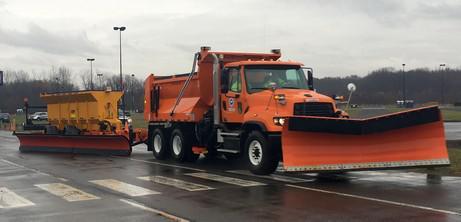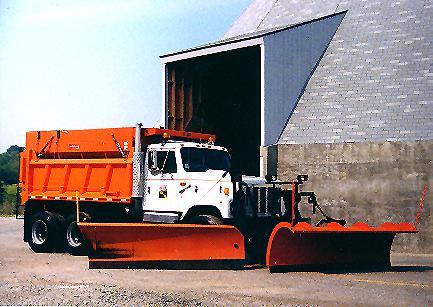The first image is the image on the left, the second image is the image on the right. Considering the images on both sides, is "An image includes a truck with an orange plow and a white cab." valid? Answer yes or no. Yes. 